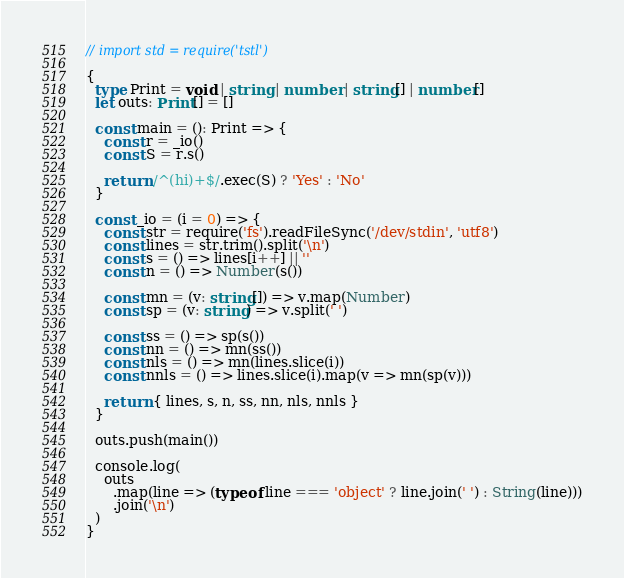Convert code to text. <code><loc_0><loc_0><loc_500><loc_500><_TypeScript_>// import std = require('tstl')

{
  type Print = void | string | number | string[] | number[]
  let outs: Print[] = []

  const main = (): Print => {
    const r = _io()
    const S = r.s()

    return /^(hi)+$/.exec(S) ? 'Yes' : 'No'
  }

  const _io = (i = 0) => {
    const str = require('fs').readFileSync('/dev/stdin', 'utf8')
    const lines = str.trim().split('\n')
    const s = () => lines[i++] || ''
    const n = () => Number(s())

    const mn = (v: string[]) => v.map(Number)
    const sp = (v: string) => v.split(' ')

    const ss = () => sp(s())
    const nn = () => mn(ss())
    const nls = () => mn(lines.slice(i))
    const nnls = () => lines.slice(i).map(v => mn(sp(v)))

    return { lines, s, n, ss, nn, nls, nnls }
  }

  outs.push(main())

  console.log(
    outs
      .map(line => (typeof line === 'object' ? line.join(' ') : String(line)))
      .join('\n')
  )
}
</code> 